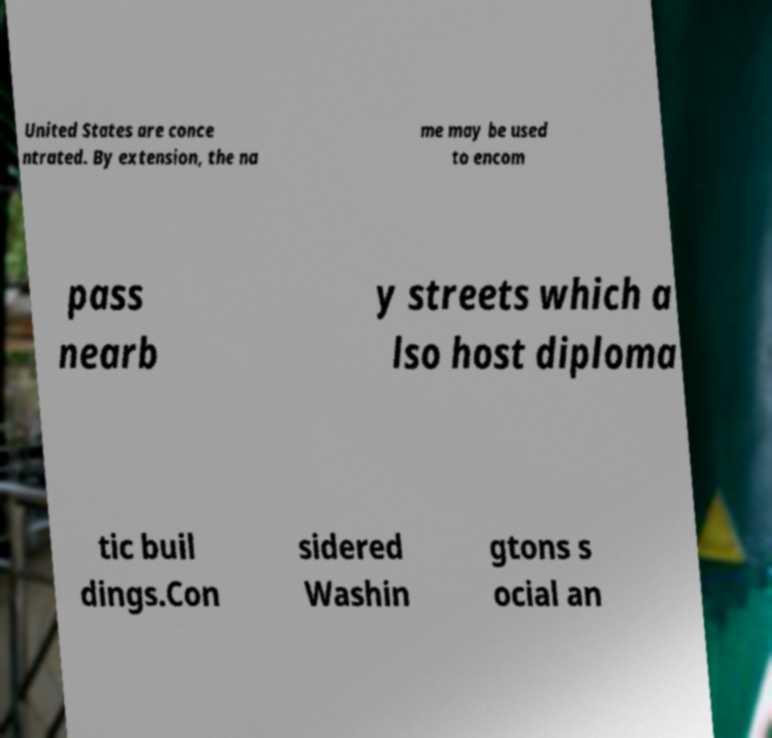For documentation purposes, I need the text within this image transcribed. Could you provide that? United States are conce ntrated. By extension, the na me may be used to encom pass nearb y streets which a lso host diploma tic buil dings.Con sidered Washin gtons s ocial an 